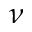<formula> <loc_0><loc_0><loc_500><loc_500>\nu</formula> 